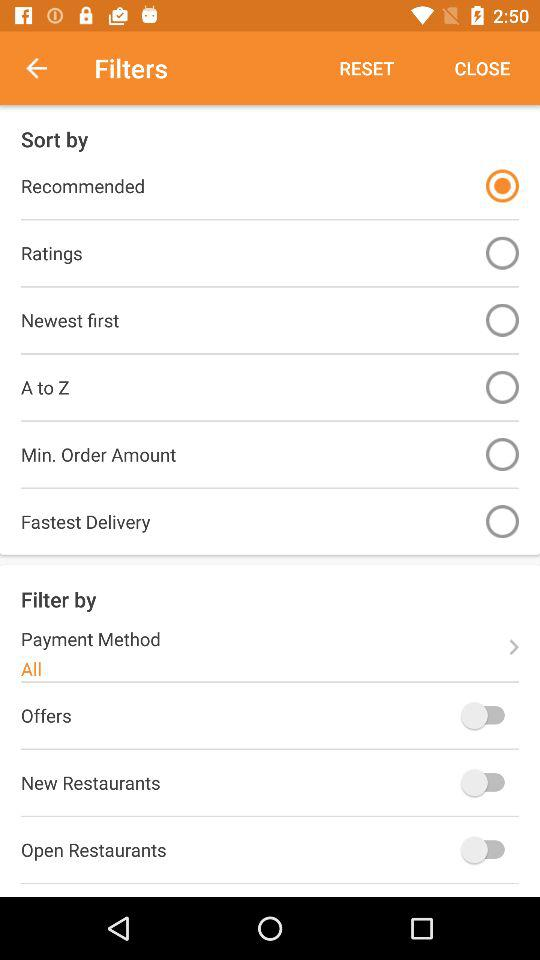What is the status of the "Offers"? The status is "off". 